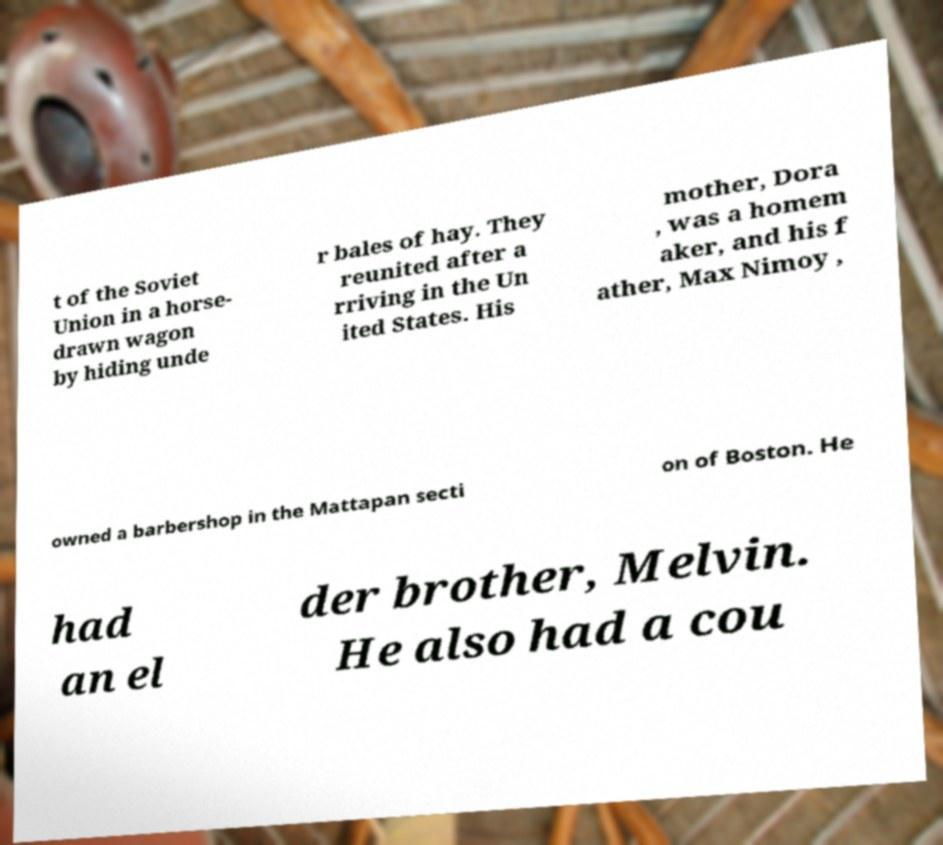There's text embedded in this image that I need extracted. Can you transcribe it verbatim? t of the Soviet Union in a horse- drawn wagon by hiding unde r bales of hay. They reunited after a rriving in the Un ited States. His mother, Dora , was a homem aker, and his f ather, Max Nimoy , owned a barbershop in the Mattapan secti on of Boston. He had an el der brother, Melvin. He also had a cou 